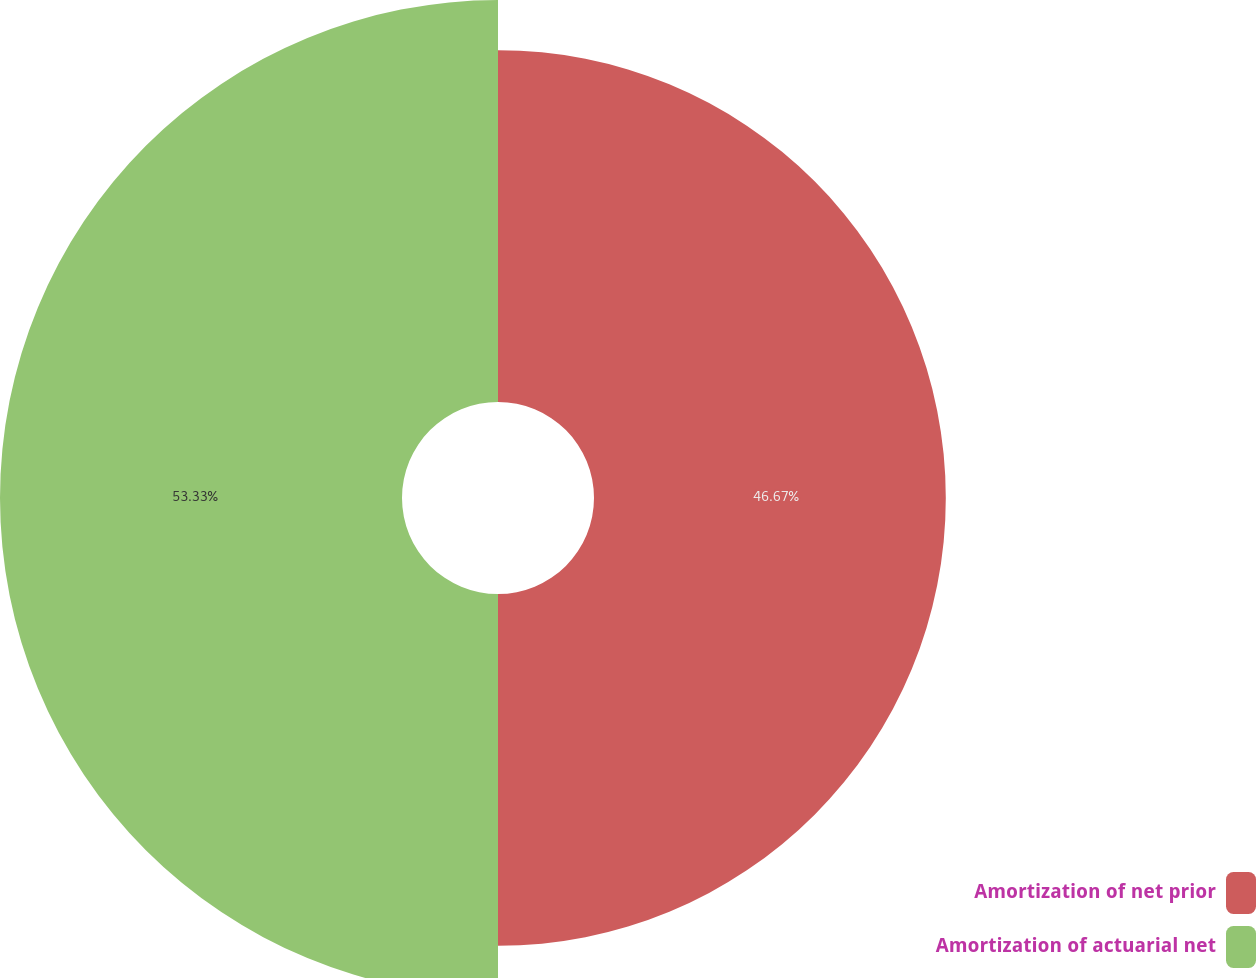<chart> <loc_0><loc_0><loc_500><loc_500><pie_chart><fcel>Amortization of net prior<fcel>Amortization of actuarial net<nl><fcel>46.67%<fcel>53.33%<nl></chart> 